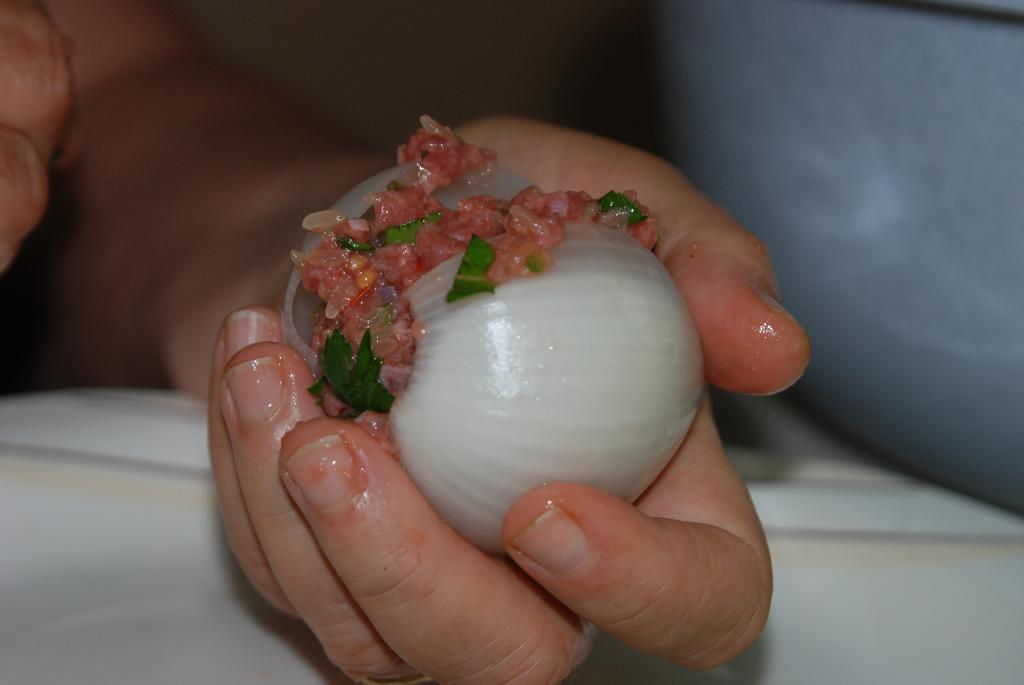What is the person's hand holding in the image? The hand is holding an onion. What is inside the onion? There is something stuffed in the onion. How many cents are visible in the image? There are no cents present in the image. How long does it take for the onion to be stuffed in the image? The duration of time it takes to stuff the onion is not visible in the image. 